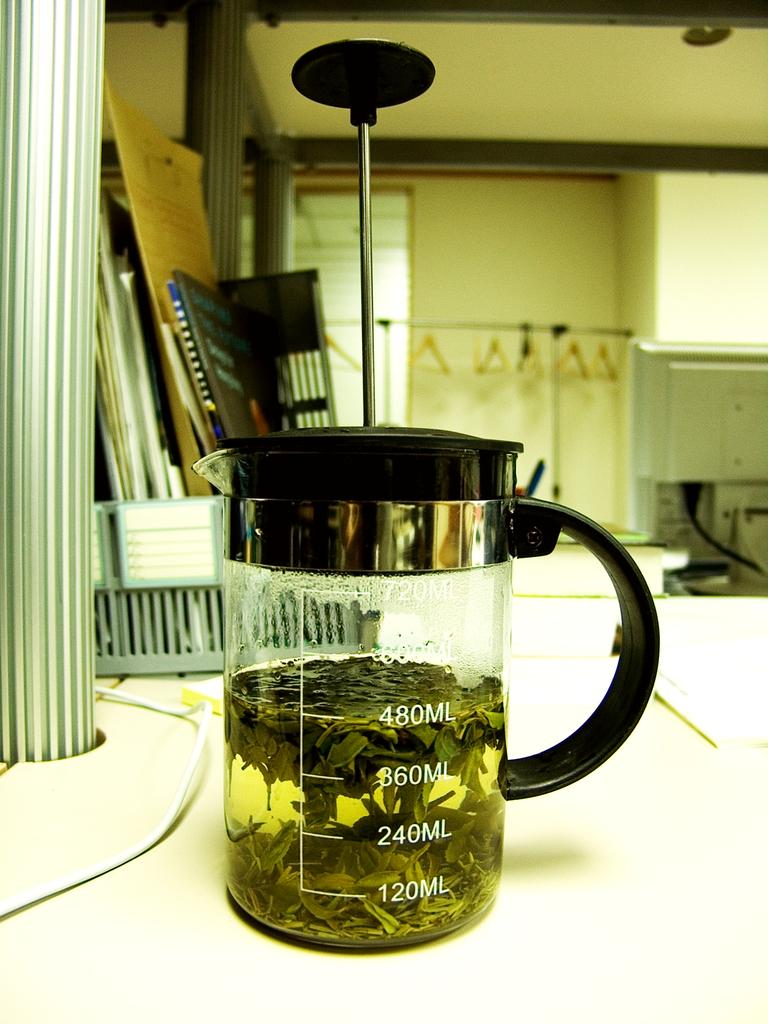<image>
Relay a brief, clear account of the picture shown. A beaker full of leave, on the side it is full to 480 ml. 